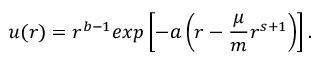Convert formula to latex. <formula><loc_0><loc_0><loc_500><loc_500>u ( r ) = r ^ { b - 1 } e x p \left [ - a \left ( r - \frac { \mu } { m } r ^ { s + 1 } \right ) \right ] .</formula> 